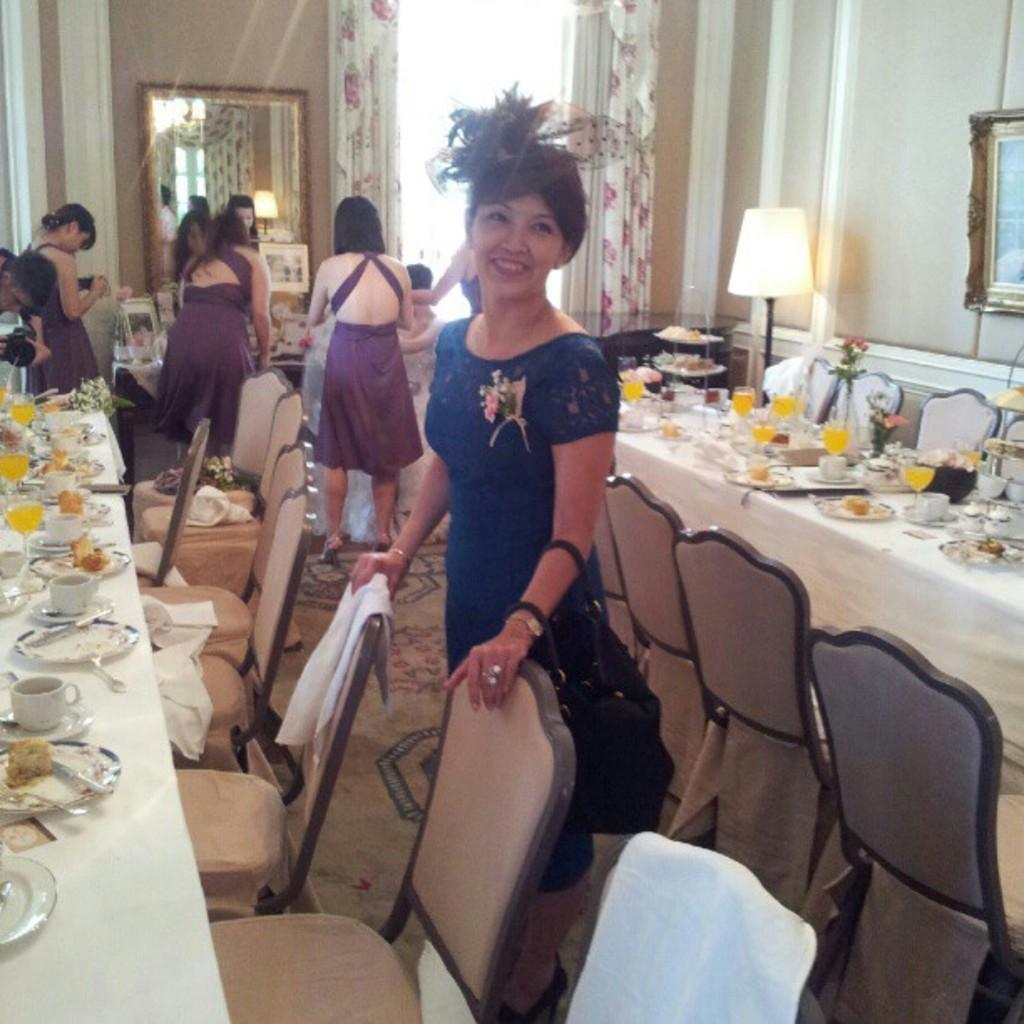In one or two sentences, can you explain what this image depicts? This picture is clicked inside the room. Here is dining table on which plate, spoon, cup, saucer, knife, glass with cool drink is placed on it. We see many chairs around this table. There are many people standing on the carpet. On the right side of the picture, we see photo frame on the wall. Next to it, we see a lamp and beside that we see curtain and on background, we see mirror. 